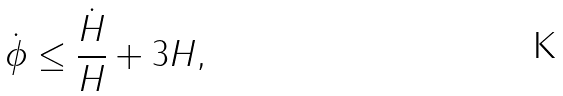Convert formula to latex. <formula><loc_0><loc_0><loc_500><loc_500>\dot { \phi } \leq \frac { \dot { H } } { H } + 3 H ,</formula> 